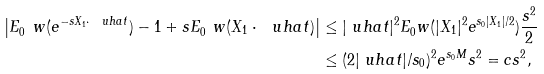Convert formula to latex. <formula><loc_0><loc_0><loc_500><loc_500>\left | E _ { 0 } ^ { \ } w ( e ^ { - { s } X _ { 1 } \cdot \ u h a t } ) - 1 + { s } E _ { 0 } ^ { \ } w ( X _ { 1 } \cdot \ u h a t ) \right | & \leq | \ u h a t | ^ { 2 } E _ { 0 } ^ { \ } w ( | X _ { 1 } | ^ { 2 } e ^ { { s } _ { 0 } | X _ { 1 } | / 2 } ) \frac { { s } ^ { 2 } } 2 \\ & \leq ( 2 | \ u h a t | / { s } _ { 0 } ) ^ { 2 } e ^ { { s } _ { 0 } M } { s } ^ { 2 } = c { s } ^ { 2 } ,</formula> 